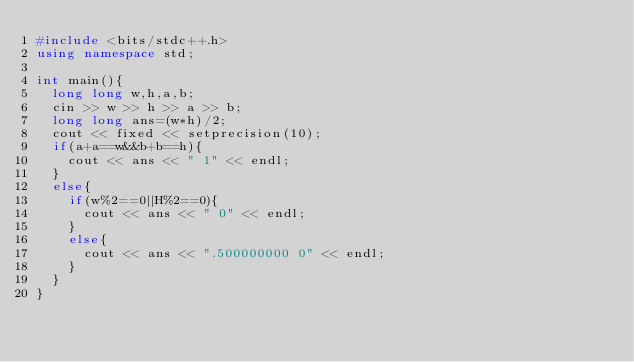<code> <loc_0><loc_0><loc_500><loc_500><_C++_>#include <bits/stdc++.h>
using namespace std;
 
int main(){
  long long w,h,a,b;
  cin >> w >> h >> a >> b;
  long long ans=(w*h)/2;
  cout << fixed << setprecision(10);
  if(a+a==w&&b+b==h){
    cout << ans << " 1" << endl;
  }
  else{
    if(w%2==0||H%2==0){
      cout << ans << " 0" << endl;
    }
    else{
      cout << ans << ".500000000 0" << endl;
    }
  }
}
</code> 